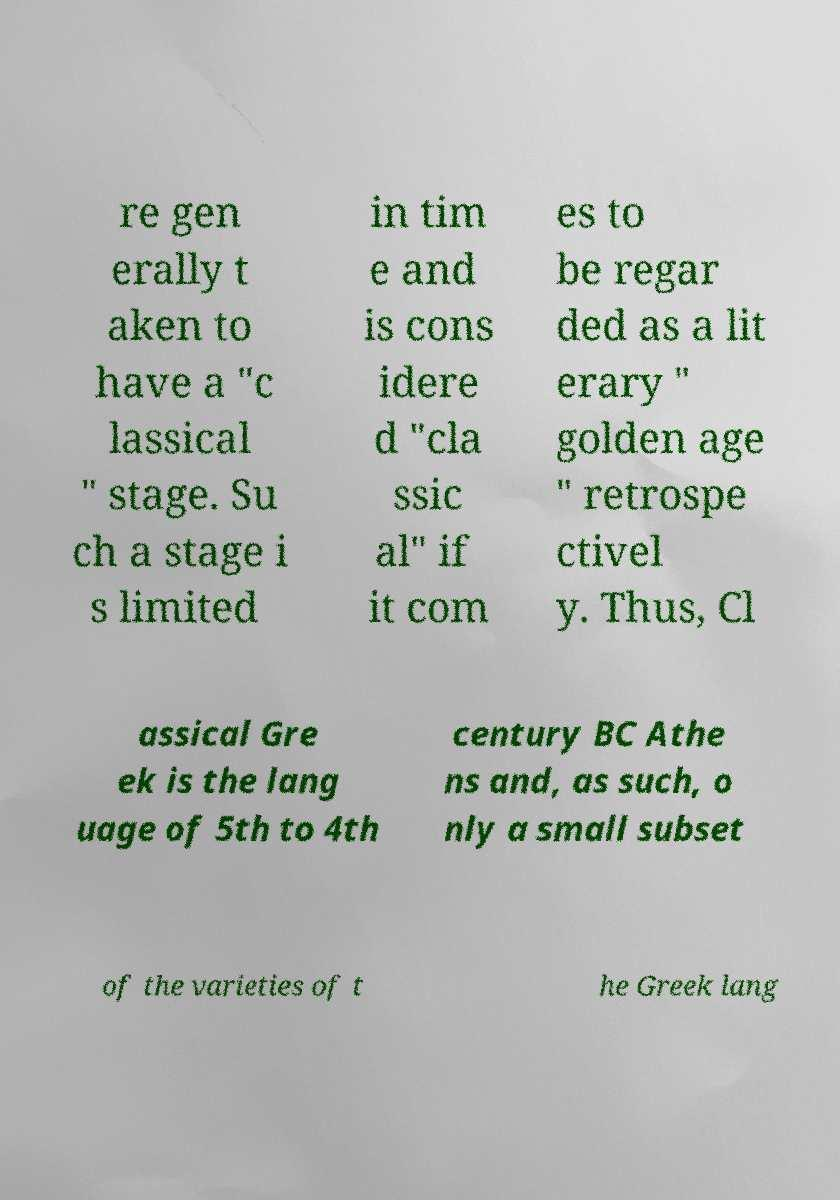Could you extract and type out the text from this image? re gen erally t aken to have a "c lassical " stage. Su ch a stage i s limited in tim e and is cons idere d "cla ssic al" if it com es to be regar ded as a lit erary " golden age " retrospe ctivel y. Thus, Cl assical Gre ek is the lang uage of 5th to 4th century BC Athe ns and, as such, o nly a small subset of the varieties of t he Greek lang 